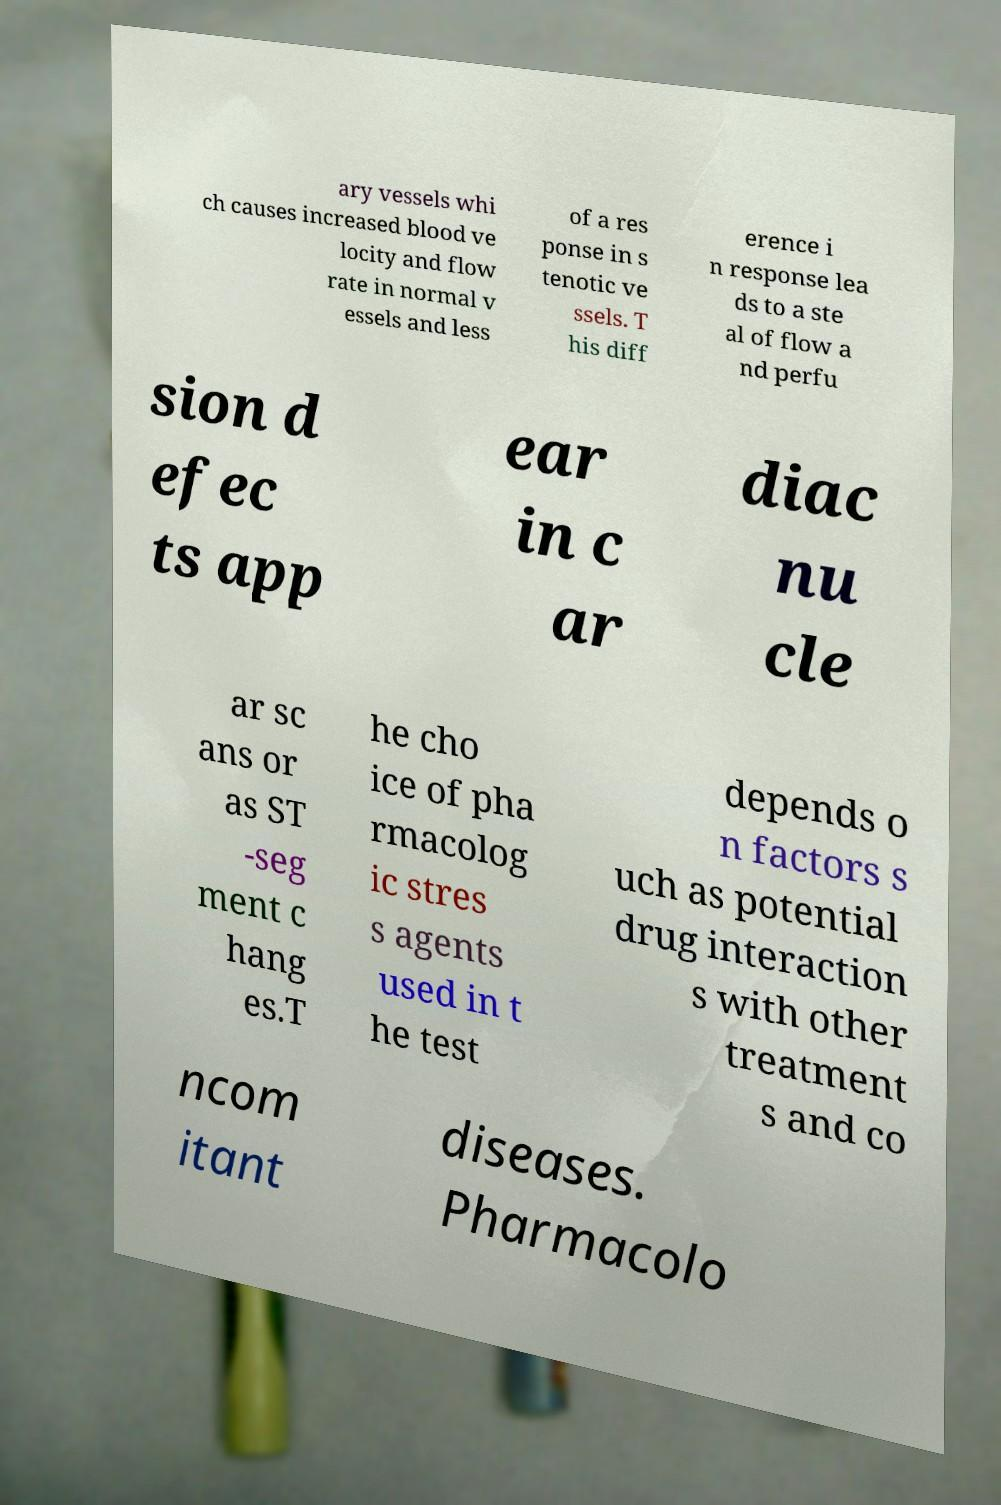For documentation purposes, I need the text within this image transcribed. Could you provide that? ary vessels whi ch causes increased blood ve locity and flow rate in normal v essels and less of a res ponse in s tenotic ve ssels. T his diff erence i n response lea ds to a ste al of flow a nd perfu sion d efec ts app ear in c ar diac nu cle ar sc ans or as ST -seg ment c hang es.T he cho ice of pha rmacolog ic stres s agents used in t he test depends o n factors s uch as potential drug interaction s with other treatment s and co ncom itant diseases. Pharmacolo 